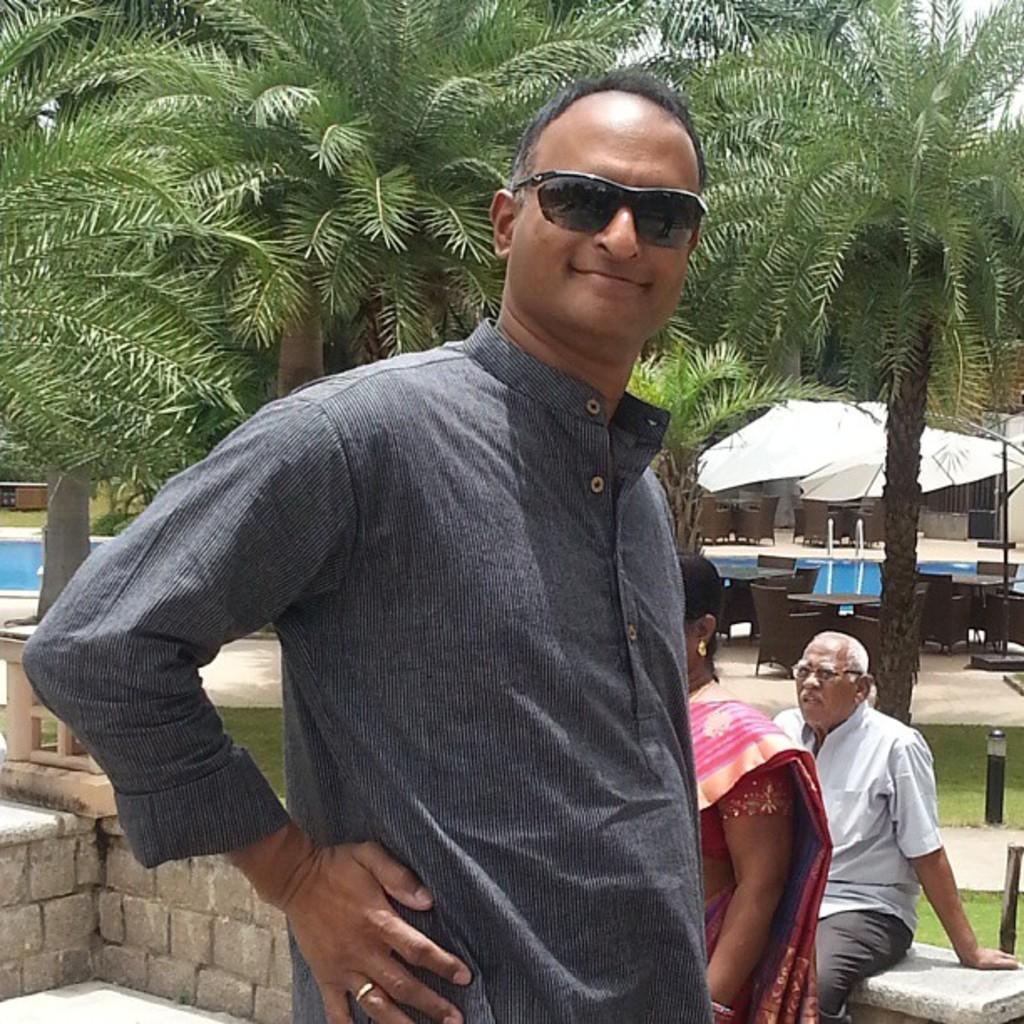Could you give a brief overview of what you see in this image? In this image I can see three people with different color dresses. In the background I can see the trees, tents and the water. I can also see the sky in the back. 